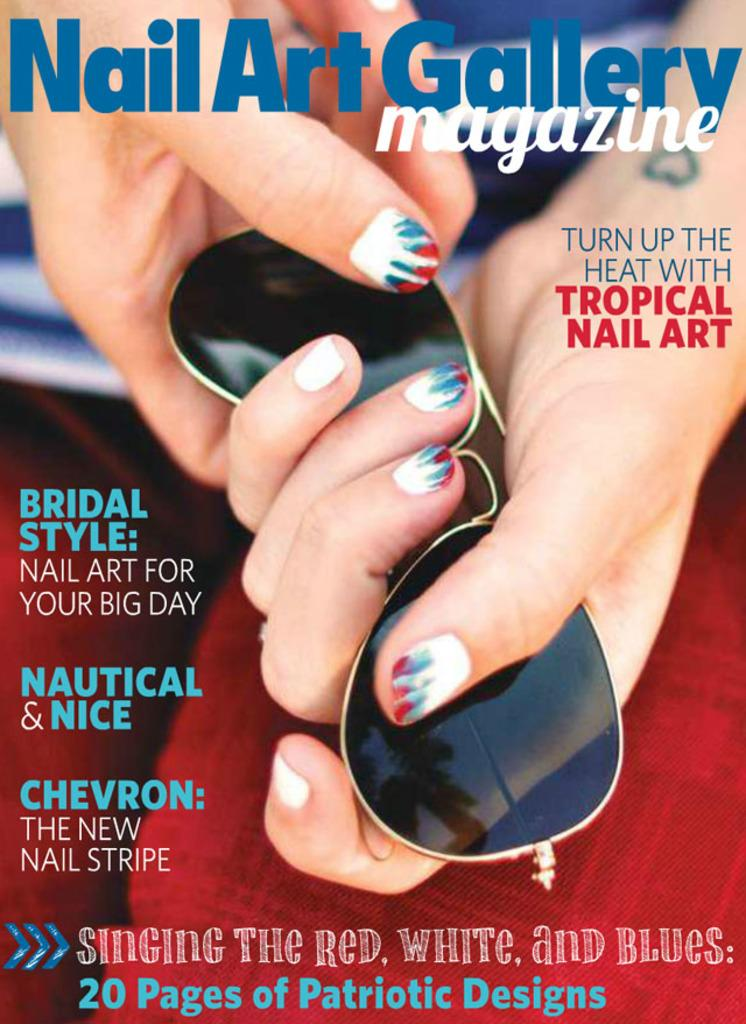<image>
Describe the image concisely. A magazine called Nail Art Gallery shows a person's hands holding sunglasses. 